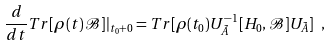<formula> <loc_0><loc_0><loc_500><loc_500>\frac { d } { d t } T r [ \rho ( t ) \mathcal { B } ] | _ { t _ { 0 } + 0 } = T r [ \rho ( t _ { 0 } ) U _ { \tilde { A } } ^ { - 1 } [ H _ { 0 } , \mathcal { B } ] U _ { \tilde { A } } ] \ ,</formula> 